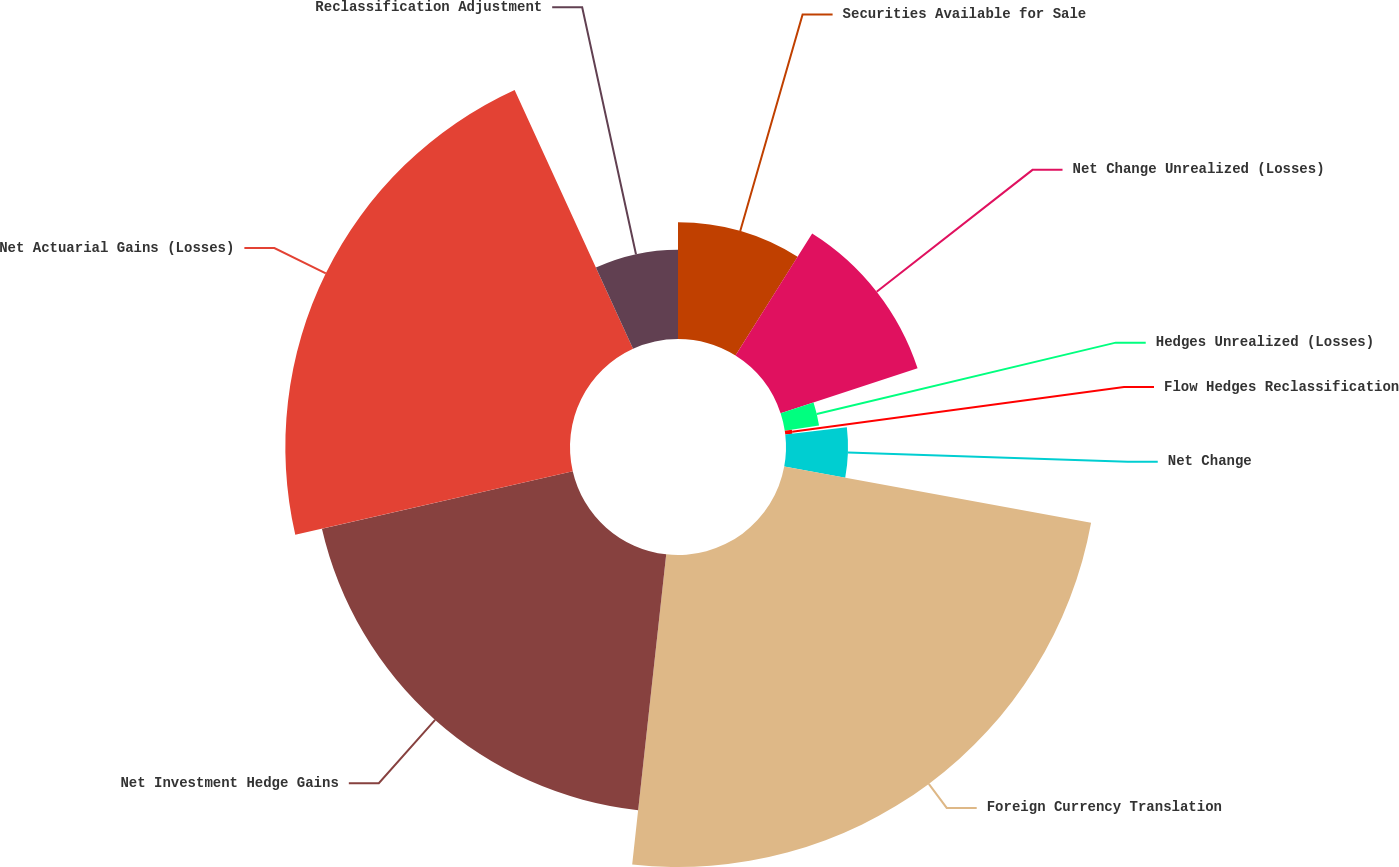Convert chart. <chart><loc_0><loc_0><loc_500><loc_500><pie_chart><fcel>Securities Available for Sale<fcel>Net Change Unrealized (Losses)<fcel>Hedges Unrealized (Losses)<fcel>Flow Hedges Reclassification<fcel>Net Change<fcel>Foreign Currency Translation<fcel>Net Investment Hedge Gains<fcel>Net Actuarial Gains (Losses)<fcel>Reclassification Adjustment<nl><fcel>8.93%<fcel>11.02%<fcel>2.65%<fcel>0.55%<fcel>4.74%<fcel>23.85%<fcel>19.67%<fcel>21.76%<fcel>6.83%<nl></chart> 